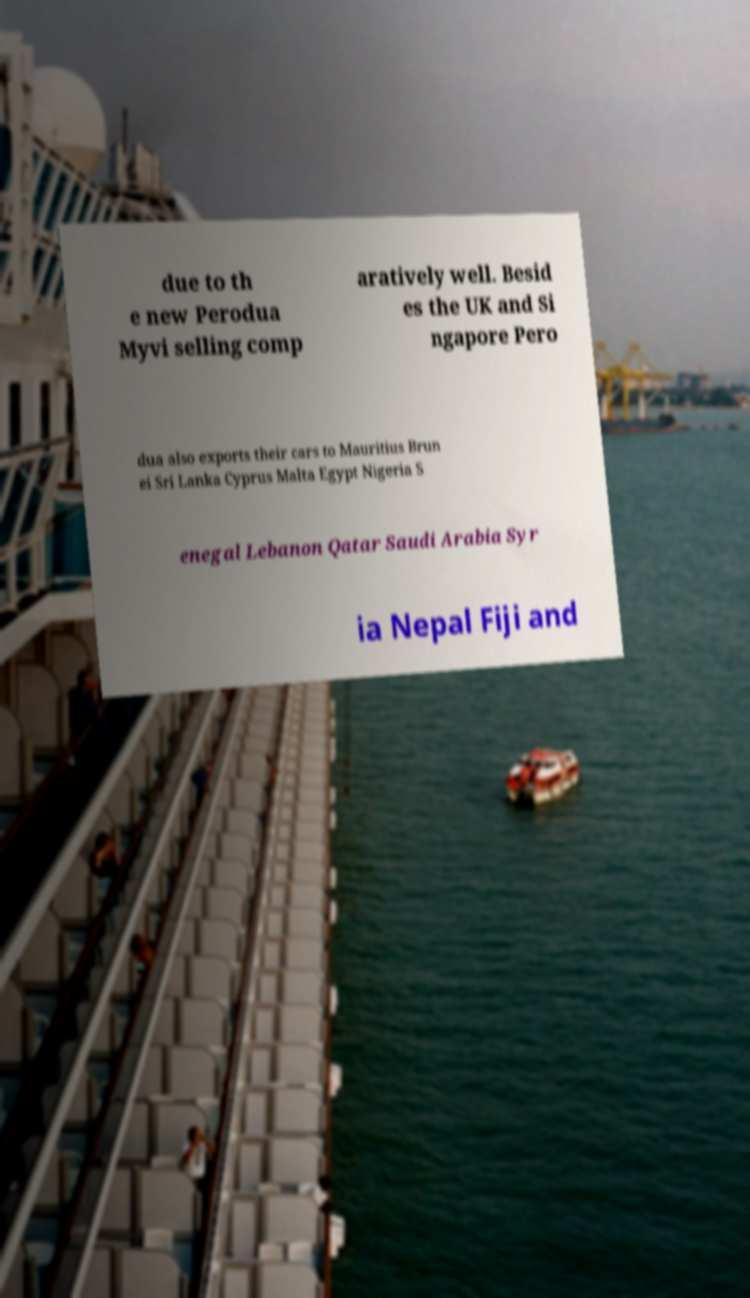What messages or text are displayed in this image? I need them in a readable, typed format. due to th e new Perodua Myvi selling comp aratively well. Besid es the UK and Si ngapore Pero dua also exports their cars to Mauritius Brun ei Sri Lanka Cyprus Malta Egypt Nigeria S enegal Lebanon Qatar Saudi Arabia Syr ia Nepal Fiji and 